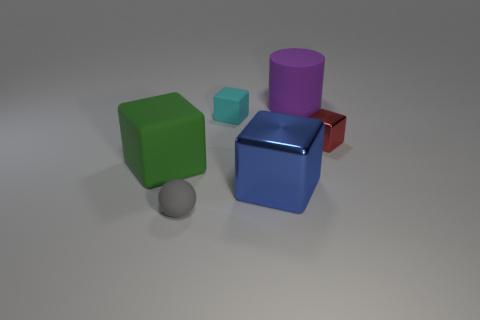Subtract 1 blocks. How many blocks are left? 3 Add 2 balls. How many objects exist? 8 Subtract all cylinders. How many objects are left? 5 Subtract all big purple matte cylinders. Subtract all large blue shiny cubes. How many objects are left? 4 Add 2 gray things. How many gray things are left? 3 Add 6 purple matte things. How many purple matte things exist? 7 Subtract 0 gray cylinders. How many objects are left? 6 